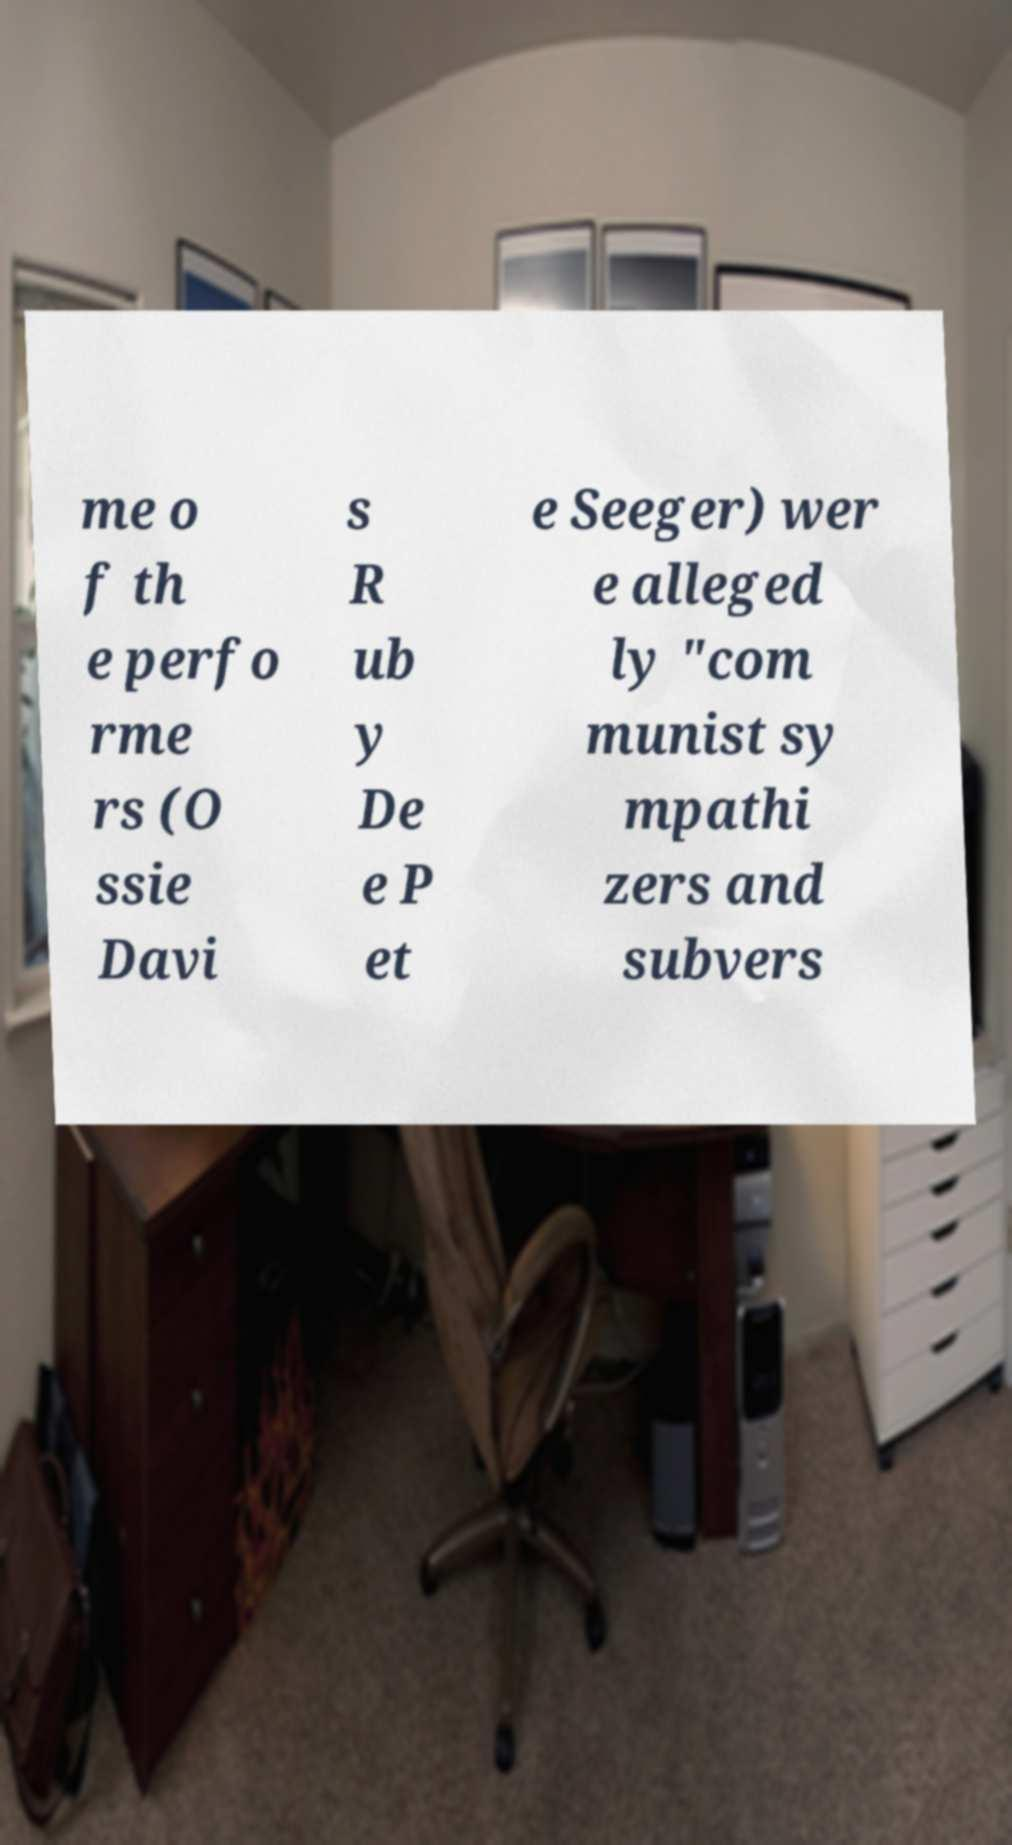What could be the consequences for the individuals named in this document during that era? For individuals like Ossie Davis, Ruby Dee, and Pete Seeger, being labeled as communist sympathizers could lead to being blacklisted in their professional fields, facing social ostracism, and being under surveillance by government agencies. It could severely impact their careers, personal lives, and the ability to find work in their industry. 